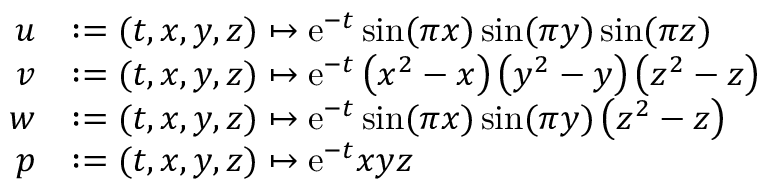<formula> <loc_0><loc_0><loc_500><loc_500>\begin{array} { r l } { u } & { \colon = ( t , x , y , z ) \mapsto e ^ { - t } \sin ( \pi x ) \sin ( \pi y ) \sin ( \pi z ) } \\ { v } & { \colon = ( t , x , y , z ) \mapsto e ^ { - t } \left ( x ^ { 2 } - x \right ) \left ( y ^ { 2 } - y \right ) \left ( z ^ { 2 } - z \right ) } \\ { w } & { \colon = ( t , x , y , z ) \mapsto e ^ { - t } \sin ( \pi x ) \sin ( \pi y ) \left ( z ^ { 2 } - z \right ) } \\ { p } & { \colon = ( t , x , y , z ) \mapsto e ^ { - t } x y z } \end{array}</formula> 